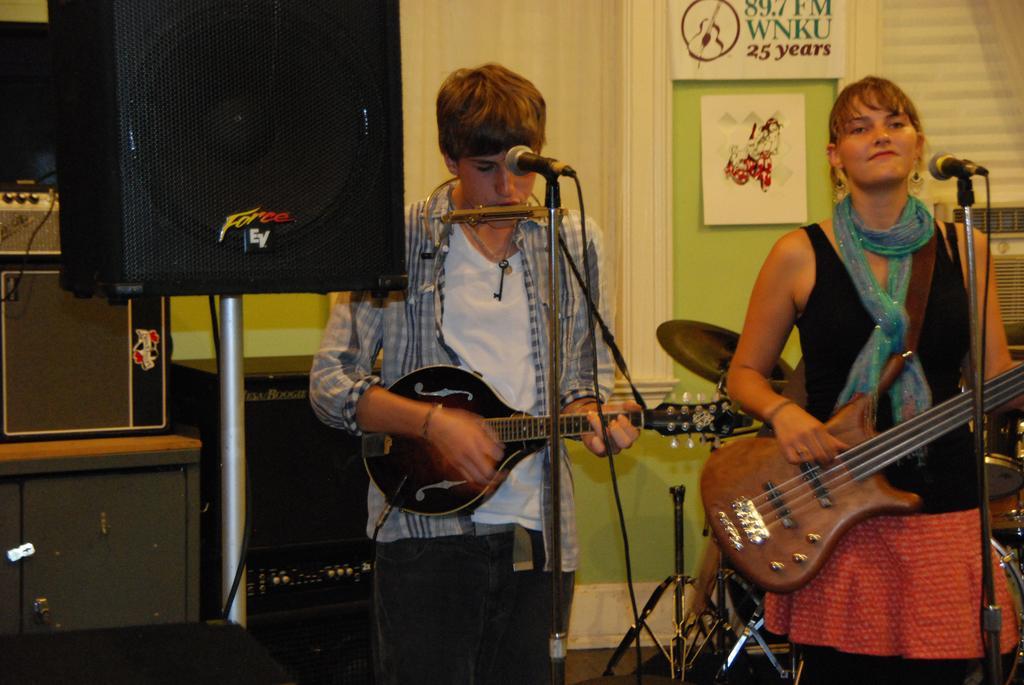In one or two sentences, can you explain what this image depicts? In this picture we can see man and woman holding guitar in their hand and playing and in front of them we have mics and in background we can see speakers, wall, posters. 